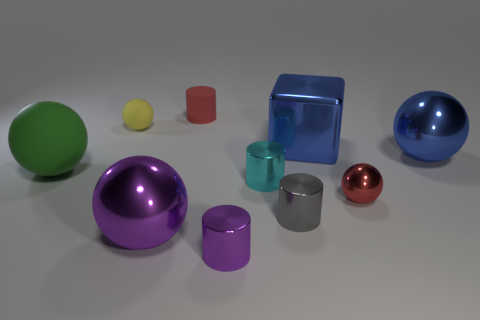How many objects are there in total, and can you describe their colors? There are nine objects in the image. Starting from the left, there's a green sphere, a small yellow sphere, a short red cylinder, a large blue transparent cube, a medium-sized purple sphere, a small teal cylinder, a large purple cylinder, a small silver cylinder, and a small red sphere.  Which object appears to be the largest, and which one seems to be the smallest? The blue transparent cube appears to be the largest object in the image. The smallest object seems to be the small yellow sphere towards the left side of the arrangement. 